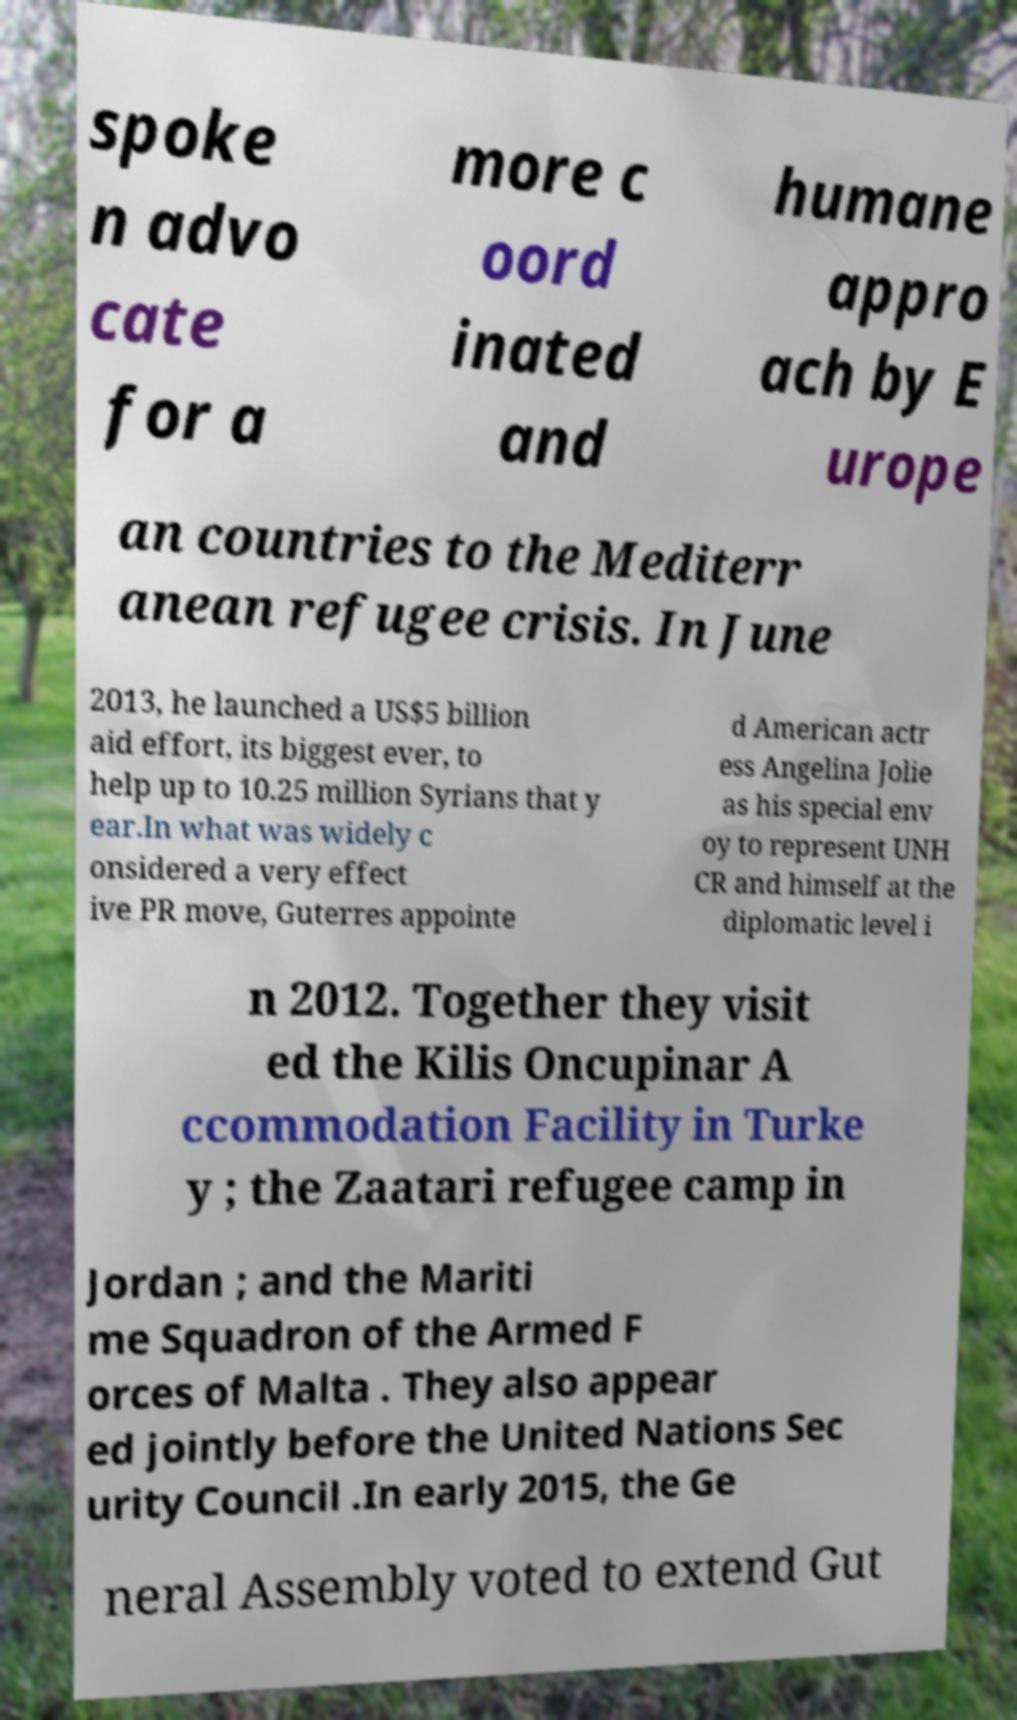There's text embedded in this image that I need extracted. Can you transcribe it verbatim? spoke n advo cate for a more c oord inated and humane appro ach by E urope an countries to the Mediterr anean refugee crisis. In June 2013, he launched a US$5 billion aid effort, its biggest ever, to help up to 10.25 million Syrians that y ear.In what was widely c onsidered a very effect ive PR move, Guterres appointe d American actr ess Angelina Jolie as his special env oy to represent UNH CR and himself at the diplomatic level i n 2012. Together they visit ed the Kilis Oncupinar A ccommodation Facility in Turke y ; the Zaatari refugee camp in Jordan ; and the Mariti me Squadron of the Armed F orces of Malta . They also appear ed jointly before the United Nations Sec urity Council .In early 2015, the Ge neral Assembly voted to extend Gut 